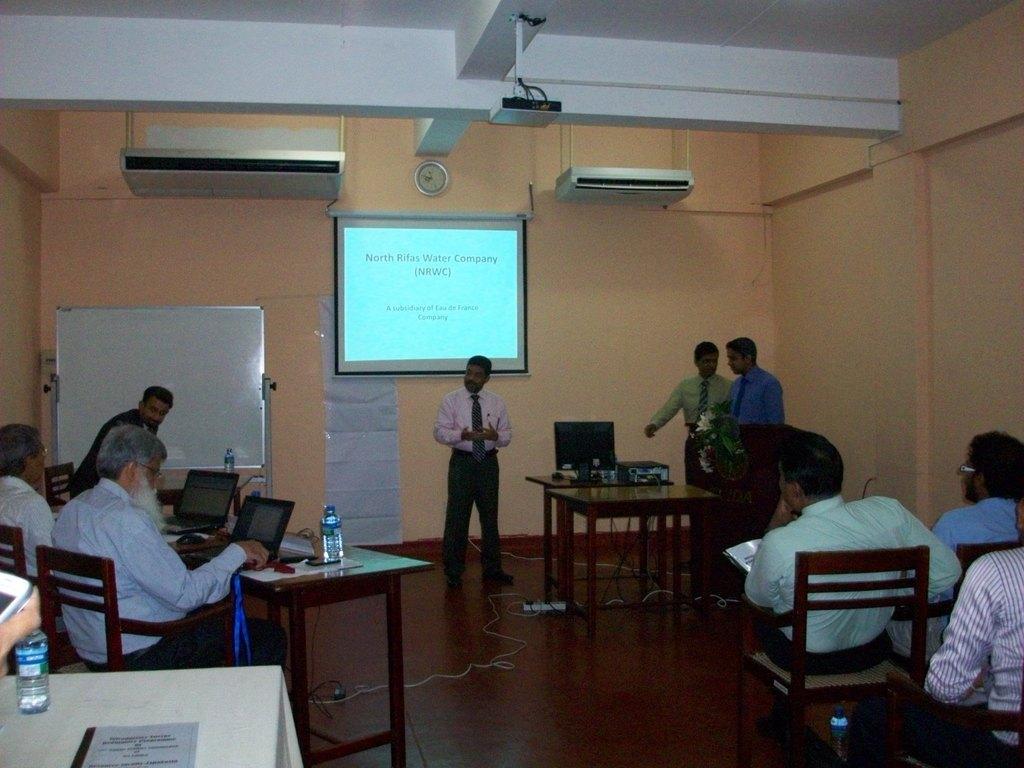Could you give a brief overview of what you see in this image? In this image we can see some people sitting on the chairs on the right side of the image, in the middle we can see a man standing is presenting something, in the background we can see a projector screen, on the right side of the image there are two people standing, on the left side of the image there two person sitting on chairs in front of a table looking at their laptops, on the top of image can see a projector here, we can also see a bottle on this table. 